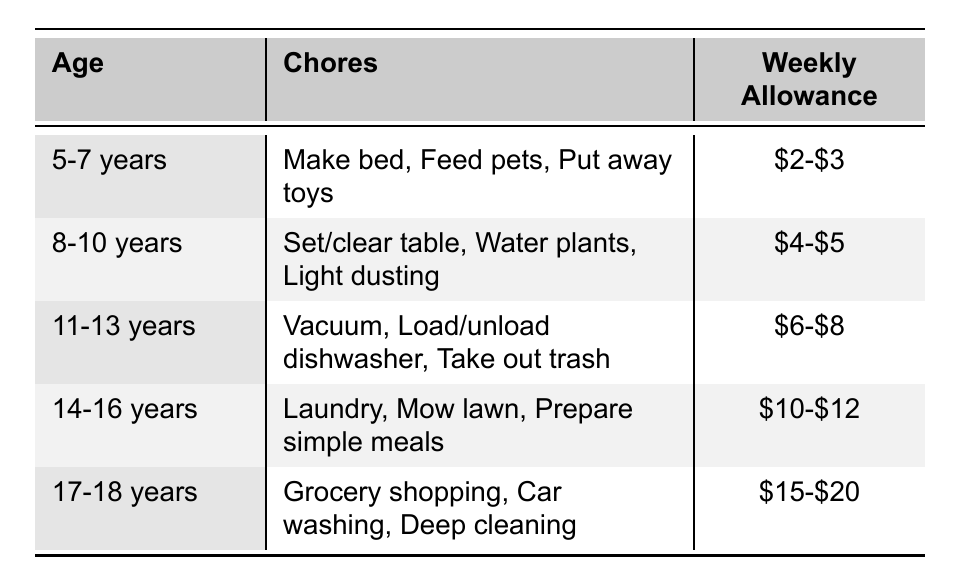What chores can a 5-7 year old do? According to the table, children aged 5-7 years can make their bed, feed pets, and put away toys.
Answer: Make bed, Feed pets, Put away toys What is the weekly allowance for children aged 14-16 years? The table indicates that children aged 14-16 years receive a weekly allowance of $10-$12.
Answer: $10-$12 If a child earns $4 this week, how does that compare to the suggested allowance for ages 8-10? The suggested allowance for ages 8-10 years is $4-$5, which means $4 falls within the expected range, while it is on the lower side of the allowance scale.
Answer: On the lower side of the range Do children aged 11-13 years do laundry? The table shows that children aged 11-13 years do vacuuming, loading/unloading the dishwasher, and taking out trash, but not laundry, which is assigned to older children.
Answer: No What is the difference in weekly allowance between ages 8-10 and 14-16? The weekly allowance for ages 8-10 is $4-$5 and for ages 14-16 is $10-$12. Taking the average of $4.5 for ages 8-10 and $11 for ages 14-16, the difference is $11 - $4.5 = $6.5.
Answer: $6.5 What is the highest weekly allowance and what age group does it pertain to? The highest weekly allowance listed is $15-$20, corresponding to the age group of 17-18 years.
Answer: $15-$20 for ages 17-18 Are there any children aged 11-13 responsible for watering plants? No, watering plants is a chore assigned to the age group of 8-10 years, not 11-13 years, based on the table.
Answer: No What chores are common for children aged 8-10 and 11-13? By examining the chores for ages 8-10 (set/clear table, water plants, light dusting) and ages 11-13 (vacuum, load/unload dishwasher, take out trash), it can be seen that neither group overlaps in chores.
Answer: None What is the average weekly allowance for all age groups listed? The weekly allowance ranges are $2-$3, $4-$5, $6-$8, $10-$12, and $15-$20. Taking the averages: $2.5, $4.5, $7, $11, and $17.5 respectively, the total average is (2.5 + 4.5 + 7 + 11 + 17.5) / 5 = 8.1.
Answer: $8.1 Which age group has the most responsibilities? The age group of 17-18 years has chores that include grocery shopping, car washing, and deep cleaning, suggesting more responsibilities compared to other age groups.
Answer: 17-18 years 